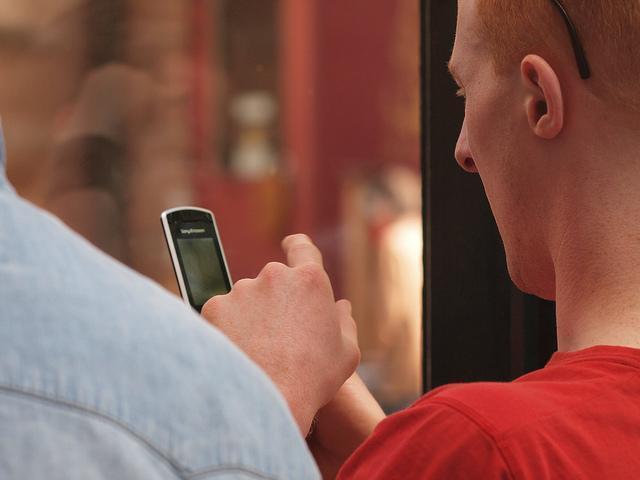How many people can you see?
Give a very brief answer. 2. How many of the buses visible on the street are two story?
Give a very brief answer. 0. 